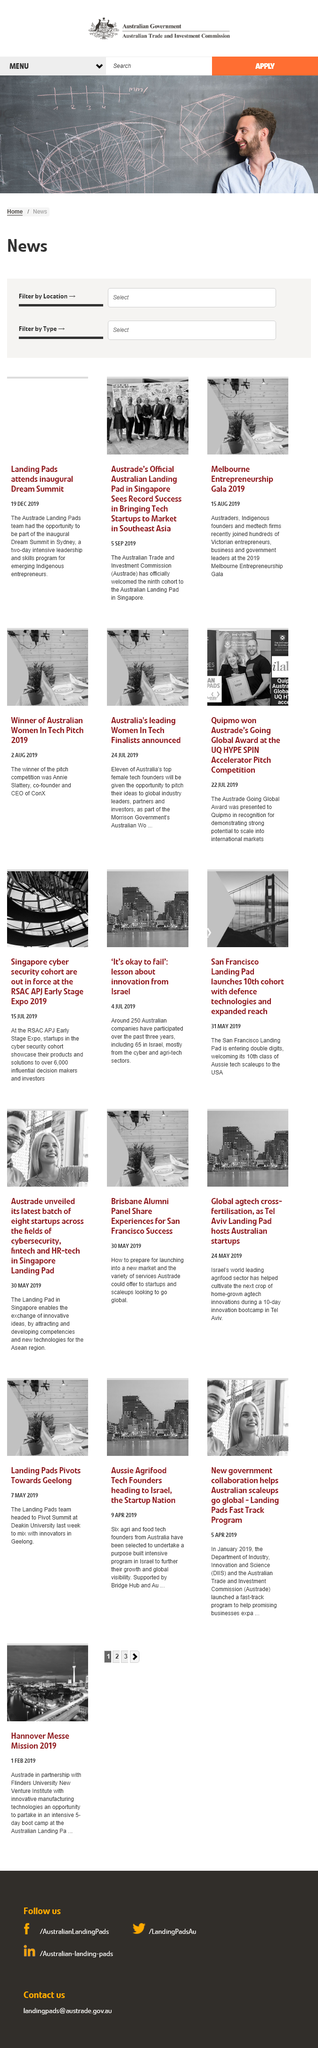Give some essential details in this illustration. The bridge depicted in the top right image can be found in San Francisco. The San Francisco Landing Pad, in 2019, was welcoming its 10th class of Aussie tech scaleups to the USA. The RSAC APJ Early Stage Expo 2019 did not receive fewer than 4,000 attendees, as it received over 6,000 attendees. 